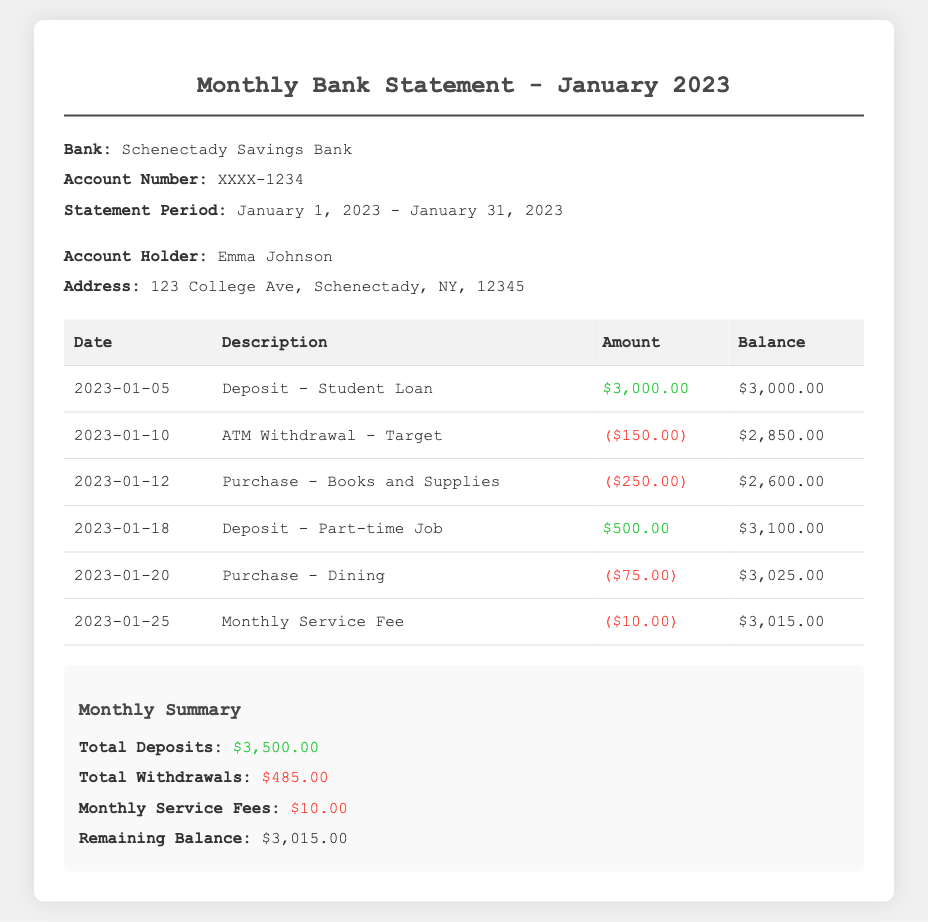What is the name of the bank? The bank is identified as "Schenectady Savings Bank" in the document.
Answer: Schenectady Savings Bank What is the account holder's name? The name of the account holder is listed as "Emma Johnson" in the account information section.
Answer: Emma Johnson How much was deposited from the student loan on January 5? The document specifies a deposit of $3,000.00 from the student loan on that date.
Answer: $3,000.00 What was the amount of the monthly service fee? The document indicates the monthly service fee is $10.00.
Answer: $10.00 What is the remaining balance at the end of January? The final balance at the end of January is stated as $3,015.00 in the summary section.
Answer: $3,015.00 How much was spent on books and supplies? The transaction for books and supplies shows an expense of $250.00.
Answer: $250.00 What was the total amount withdrawn during January? The total withdrawals are found by adding the individual withdrawals, which sum up to $485.00.
Answer: $485.00 On what date was the last transaction recorded? The last transaction date in the table is January 25.
Answer: January 25 What is the total amount deposited in January? The total deposits are the sum of all deposits in the document, which adds up to $3,500.00.
Answer: $3,500.00 